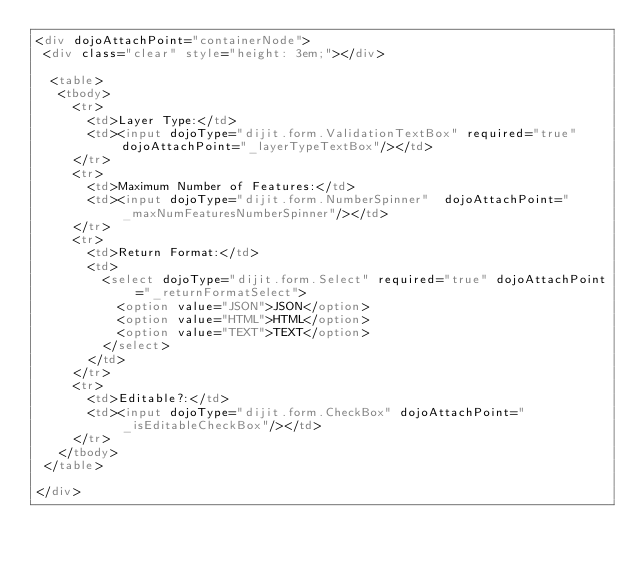Convert code to text. <code><loc_0><loc_0><loc_500><loc_500><_HTML_><div dojoAttachPoint="containerNode">
 <div class="clear" style="height: 3em;"></div>
 
  <table>
   <tbody>
     <tr>
       <td>Layer Type:</td>
       <td><input dojoType="dijit.form.ValidationTextBox" required="true" dojoAttachPoint="_layerTypeTextBox"/></td>
     </tr>
     <tr>
       <td>Maximum Number of Features:</td>
       <td><input dojoType="dijit.form.NumberSpinner"  dojoAttachPoint="_maxNumFeaturesNumberSpinner"/></td>
     </tr>
     <tr>
       <td>Return Format:</td>
       <td>
         <select dojoType="dijit.form.Select" required="true" dojoAttachPoint="_returnFormatSelect">
           <option value="JSON">JSON</option>
           <option value="HTML">HTML</option>
           <option value="TEXT">TEXT</option>
         </select>
       </td>
     </tr>
     <tr>
       <td>Editable?:</td>
       <td><input dojoType="dijit.form.CheckBox" dojoAttachPoint="_isEditableCheckBox"/></td>
     </tr>
   </tbody>
 </table>

</div>
</code> 